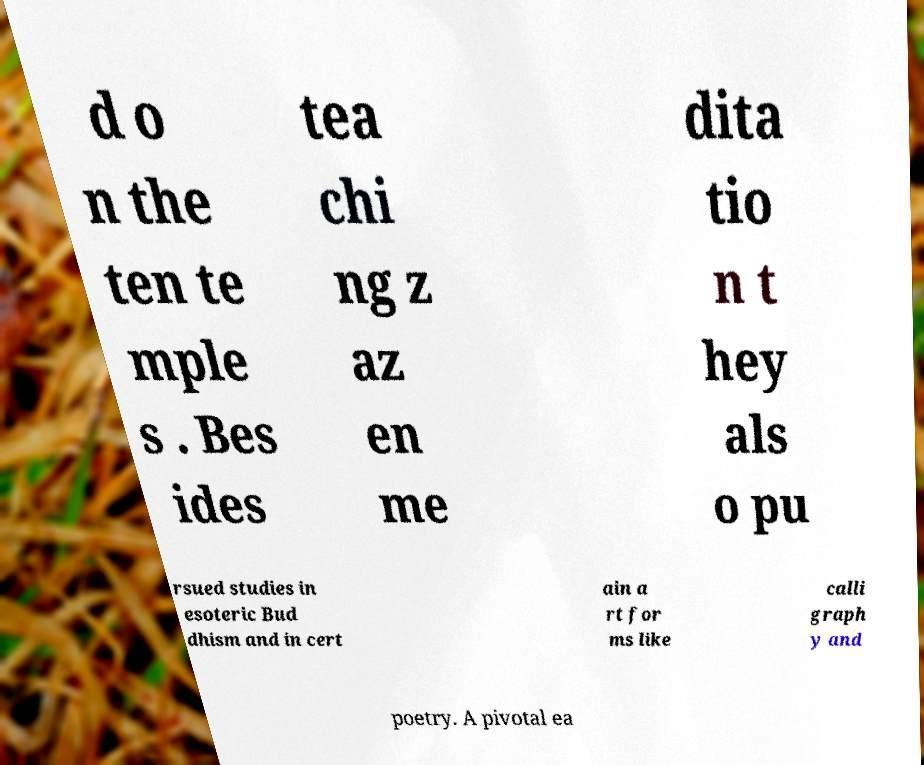I need the written content from this picture converted into text. Can you do that? d o n the ten te mple s . Bes ides tea chi ng z az en me dita tio n t hey als o pu rsued studies in esoteric Bud dhism and in cert ain a rt for ms like calli graph y and poetry. A pivotal ea 